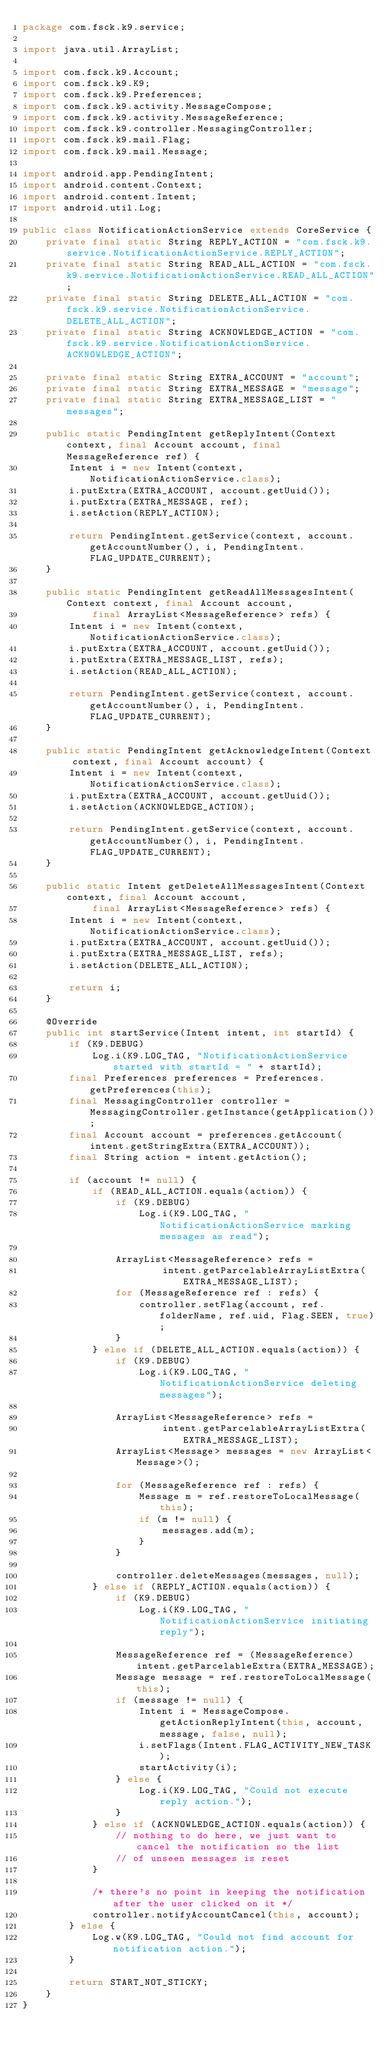Convert code to text. <code><loc_0><loc_0><loc_500><loc_500><_Java_>package com.fsck.k9.service;

import java.util.ArrayList;

import com.fsck.k9.Account;
import com.fsck.k9.K9;
import com.fsck.k9.Preferences;
import com.fsck.k9.activity.MessageCompose;
import com.fsck.k9.activity.MessageReference;
import com.fsck.k9.controller.MessagingController;
import com.fsck.k9.mail.Flag;
import com.fsck.k9.mail.Message;

import android.app.PendingIntent;
import android.content.Context;
import android.content.Intent;
import android.util.Log;

public class NotificationActionService extends CoreService {
    private final static String REPLY_ACTION = "com.fsck.k9.service.NotificationActionService.REPLY_ACTION";
    private final static String READ_ALL_ACTION = "com.fsck.k9.service.NotificationActionService.READ_ALL_ACTION";
    private final static String DELETE_ALL_ACTION = "com.fsck.k9.service.NotificationActionService.DELETE_ALL_ACTION";
    private final static String ACKNOWLEDGE_ACTION = "com.fsck.k9.service.NotificationActionService.ACKNOWLEDGE_ACTION";

    private final static String EXTRA_ACCOUNT = "account";
    private final static String EXTRA_MESSAGE = "message";
    private final static String EXTRA_MESSAGE_LIST = "messages";

    public static PendingIntent getReplyIntent(Context context, final Account account, final MessageReference ref) {
        Intent i = new Intent(context, NotificationActionService.class);
        i.putExtra(EXTRA_ACCOUNT, account.getUuid());
        i.putExtra(EXTRA_MESSAGE, ref);
        i.setAction(REPLY_ACTION);

        return PendingIntent.getService(context, account.getAccountNumber(), i, PendingIntent.FLAG_UPDATE_CURRENT);
    }

    public static PendingIntent getReadAllMessagesIntent(Context context, final Account account,
            final ArrayList<MessageReference> refs) {
        Intent i = new Intent(context, NotificationActionService.class);
        i.putExtra(EXTRA_ACCOUNT, account.getUuid());
        i.putExtra(EXTRA_MESSAGE_LIST, refs);
        i.setAction(READ_ALL_ACTION);
        
        return PendingIntent.getService(context, account.getAccountNumber(), i, PendingIntent.FLAG_UPDATE_CURRENT);
    }

    public static PendingIntent getAcknowledgeIntent(Context context, final Account account) {
        Intent i = new Intent(context, NotificationActionService.class);
        i.putExtra(EXTRA_ACCOUNT, account.getUuid());
        i.setAction(ACKNOWLEDGE_ACTION);

        return PendingIntent.getService(context, account.getAccountNumber(), i, PendingIntent.FLAG_UPDATE_CURRENT);
    }

    public static Intent getDeleteAllMessagesIntent(Context context, final Account account,
            final ArrayList<MessageReference> refs) {
        Intent i = new Intent(context, NotificationActionService.class);
        i.putExtra(EXTRA_ACCOUNT, account.getUuid());
        i.putExtra(EXTRA_MESSAGE_LIST, refs);
        i.setAction(DELETE_ALL_ACTION);

        return i;
    }

    @Override
    public int startService(Intent intent, int startId) {
        if (K9.DEBUG)
            Log.i(K9.LOG_TAG, "NotificationActionService started with startId = " + startId);
        final Preferences preferences = Preferences.getPreferences(this);
        final MessagingController controller = MessagingController.getInstance(getApplication());
        final Account account = preferences.getAccount(intent.getStringExtra(EXTRA_ACCOUNT));
        final String action = intent.getAction();

        if (account != null) {
            if (READ_ALL_ACTION.equals(action)) {
                if (K9.DEBUG)
                    Log.i(K9.LOG_TAG, "NotificationActionService marking messages as read");

                ArrayList<MessageReference> refs =
                        intent.getParcelableArrayListExtra(EXTRA_MESSAGE_LIST);
                for (MessageReference ref : refs) {
                    controller.setFlag(account, ref.folderName, ref.uid, Flag.SEEN, true);
                }
            } else if (DELETE_ALL_ACTION.equals(action)) {
                if (K9.DEBUG)
                    Log.i(K9.LOG_TAG, "NotificationActionService deleting messages");

                ArrayList<MessageReference> refs =
                        intent.getParcelableArrayListExtra(EXTRA_MESSAGE_LIST);
                ArrayList<Message> messages = new ArrayList<Message>();

                for (MessageReference ref : refs) {
                    Message m = ref.restoreToLocalMessage(this);
                    if (m != null) {
                        messages.add(m);
                    }
                }

                controller.deleteMessages(messages, null);
            } else if (REPLY_ACTION.equals(action)) {
                if (K9.DEBUG)
                    Log.i(K9.LOG_TAG, "NotificationActionService initiating reply");

                MessageReference ref = (MessageReference) intent.getParcelableExtra(EXTRA_MESSAGE);
                Message message = ref.restoreToLocalMessage(this);
                if (message != null) {
                    Intent i = MessageCompose.getActionReplyIntent(this, account, message, false, null);
                    i.setFlags(Intent.FLAG_ACTIVITY_NEW_TASK);
                    startActivity(i);
                } else {
                    Log.i(K9.LOG_TAG, "Could not execute reply action.");
                }
            } else if (ACKNOWLEDGE_ACTION.equals(action)) {
                // nothing to do here, we just want to cancel the notification so the list
                // of unseen messages is reset
            }

            /* there's no point in keeping the notification after the user clicked on it */
            controller.notifyAccountCancel(this, account);
        } else {
            Log.w(K9.LOG_TAG, "Could not find account for notification action.");
        }
        
        return START_NOT_STICKY;
    }
}
</code> 